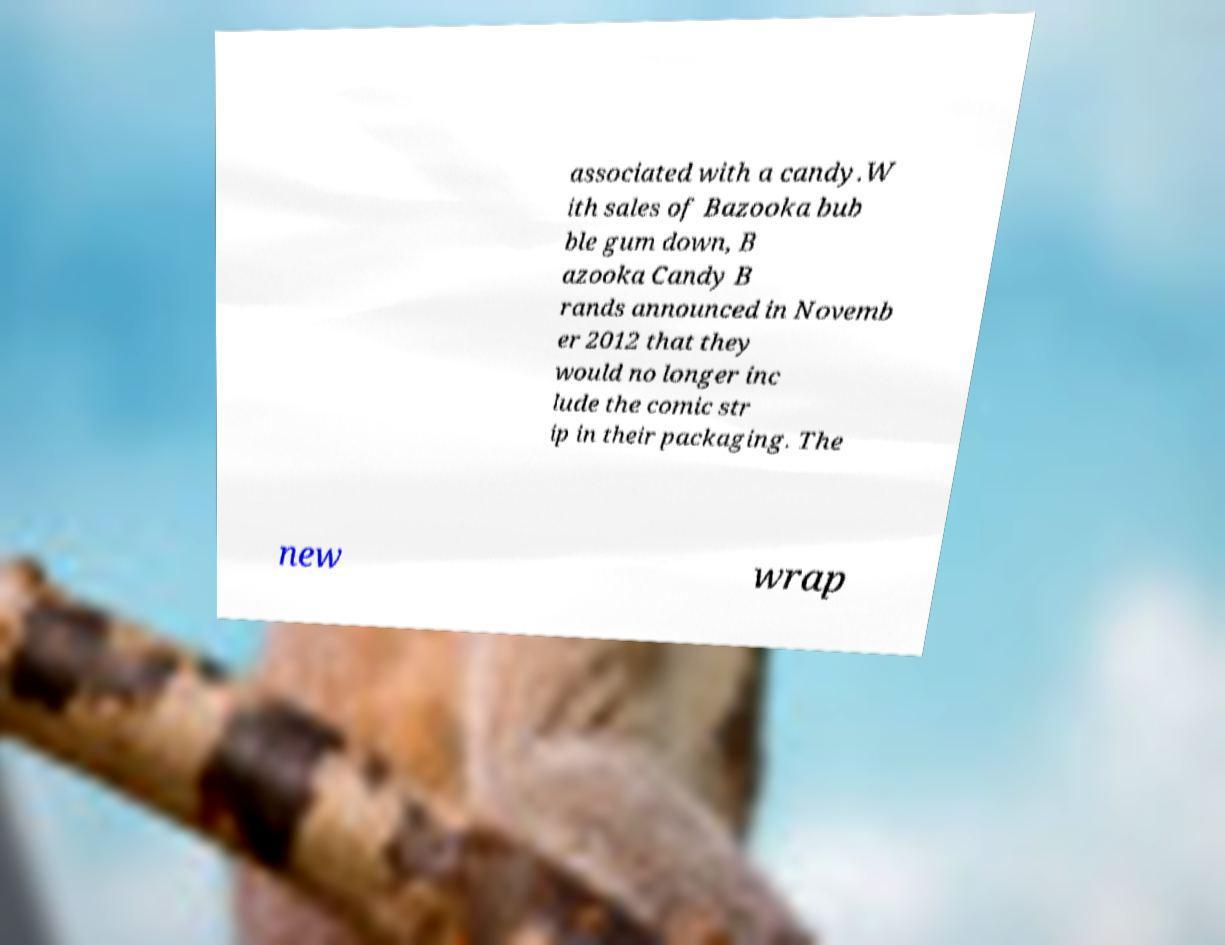I need the written content from this picture converted into text. Can you do that? associated with a candy.W ith sales of Bazooka bub ble gum down, B azooka Candy B rands announced in Novemb er 2012 that they would no longer inc lude the comic str ip in their packaging. The new wrap 